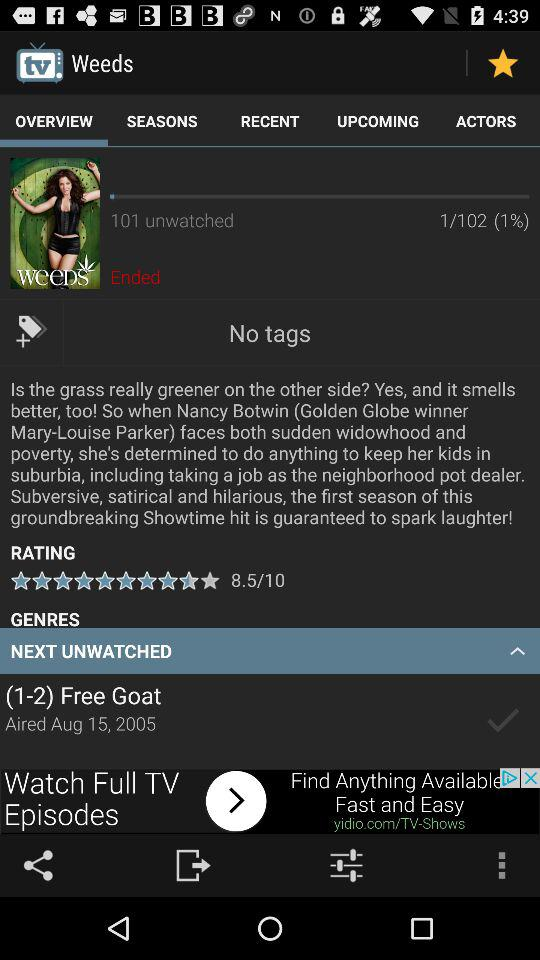How many episodes of "Weeds" are unwatched? There are 101 unwatched episodes. 